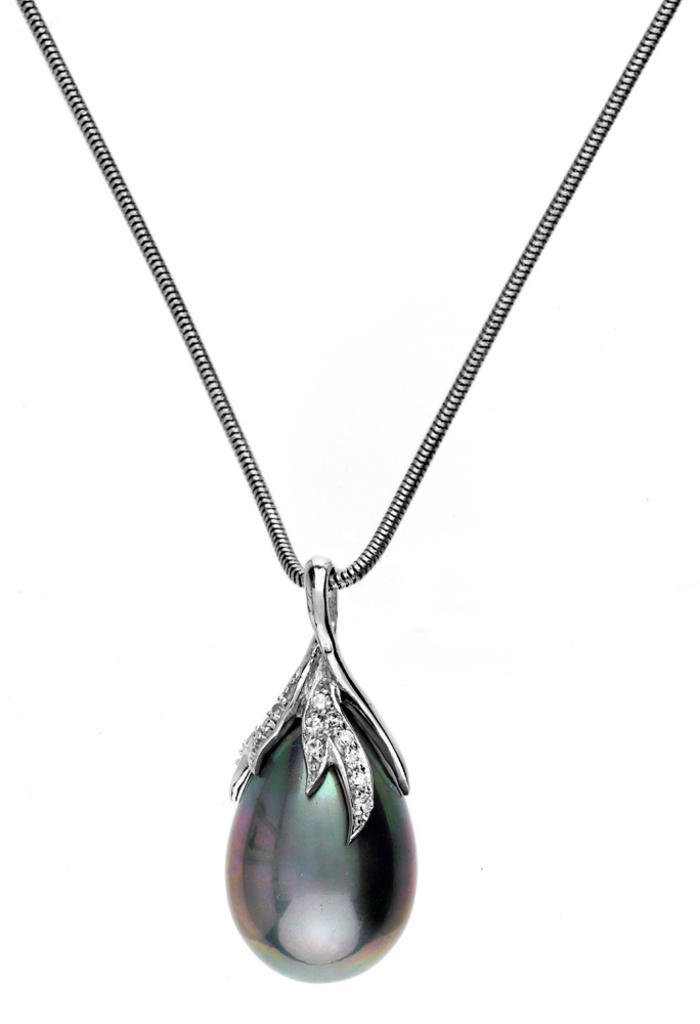Could you give a brief overview of what you see in this image? In this image I can see a locket to a chain. The background is in white color. 